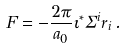<formula> <loc_0><loc_0><loc_500><loc_500>F = - \frac { 2 \pi } { a _ { 0 } } \iota ^ { * } \Sigma ^ { i } r _ { i } \, .</formula> 